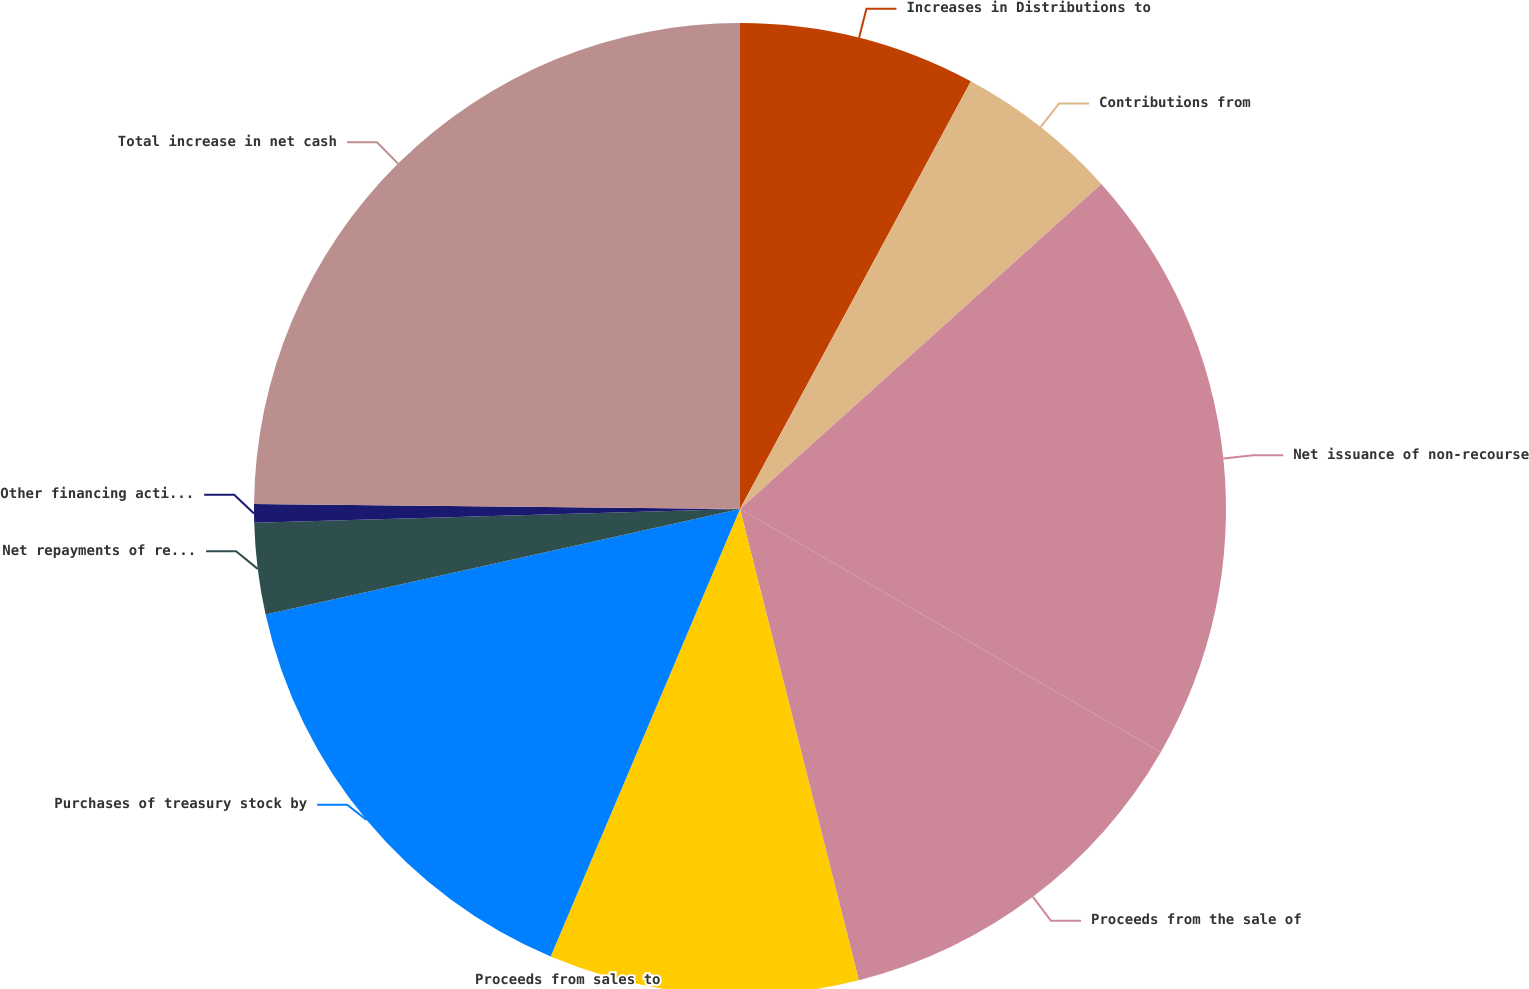Convert chart to OTSL. <chart><loc_0><loc_0><loc_500><loc_500><pie_chart><fcel>Increases in Distributions to<fcel>Contributions from<fcel>Net issuance of non-recourse<fcel>Proceeds from the sale of<fcel>Proceeds from sales to<fcel>Purchases of treasury stock by<fcel>Net repayments of recourse<fcel>Other financing activities<fcel>Total increase in net cash<nl><fcel>7.88%<fcel>5.46%<fcel>20.0%<fcel>12.73%<fcel>10.3%<fcel>15.15%<fcel>3.03%<fcel>0.61%<fcel>24.84%<nl></chart> 